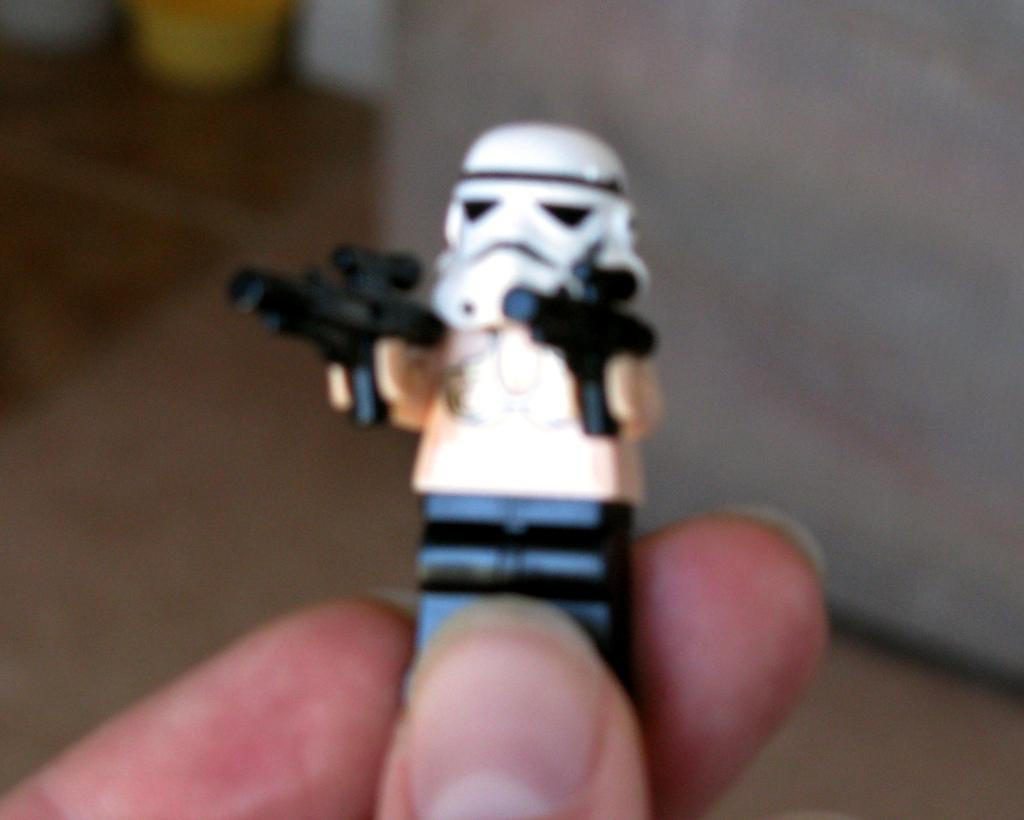What is the main subject of the image? There is a small toy in the image. Where is the toy located in the image? The toy is in the center of the image. How is the toy being held in the image? The toy is being held in a hand. What hobbies does the duck in the image enjoy? There is no duck present in the image; it features a small toy being held in a hand. 